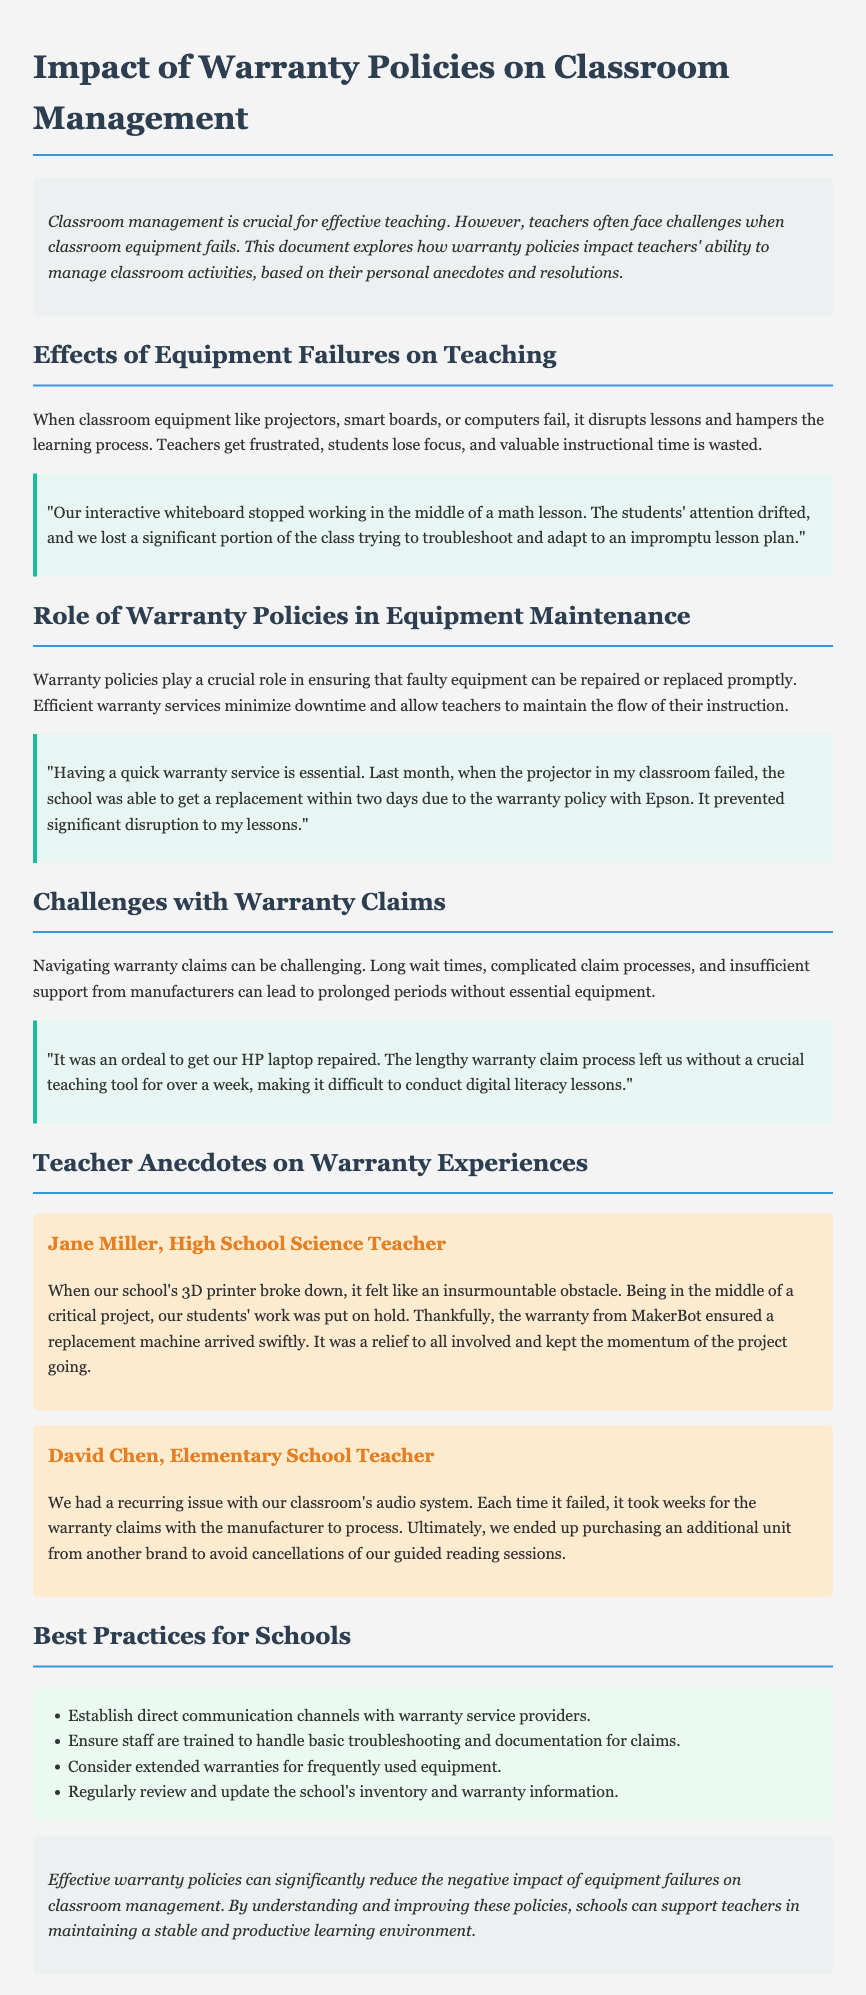What are some common equipment failures mentioned? The document mentions equipment failures such as projectors, smart boards, and computers that disrupt lessons.
Answer: projectors, smart boards, computers How long did it take for David Chen's school's warranty claims to process? David Chen mentions that each time their classroom's audio system failed, it took weeks to process the warranty claims.
Answer: weeks Who experienced a problem with a 3D printer? Jane Miller, a high school science teacher, experienced a problem with a 3D printer.
Answer: Jane Miller What is one best practice suggested for schools regarding warranties? The document suggests establishing direct communication channels with warranty service providers as a best practice.
Answer: Establish direct communication channels What critical project was affected by equipment failure? Jane Miller's students' work on a critical project was put on hold due to the breakdown of the 3D printer.
Answer: critical project What can effective warranty policies significantly reduce? Effective warranty policies can significantly reduce the negative impact of equipment failures on classroom management.
Answer: negative impact 